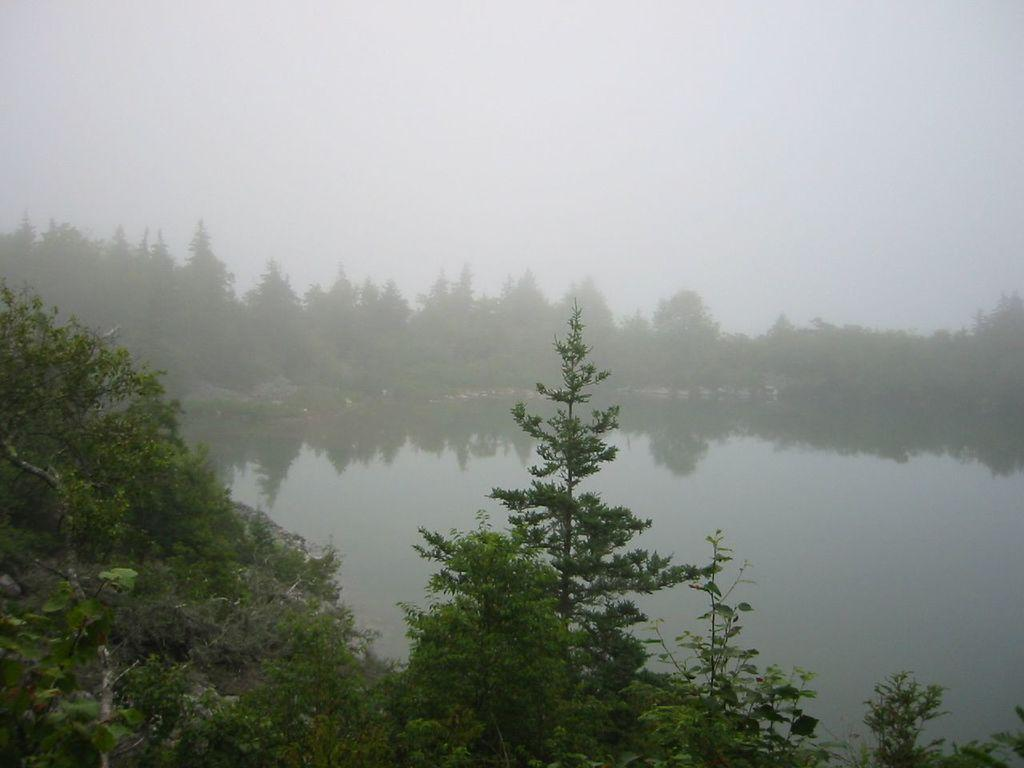What type of vegetation can be seen in the image? There are trees in the image. What natural element is visible alongside the trees? There is water visible in the image. What part of the natural environment is visible in the image? The sky is visible in the image. What type of amusement can be seen in the image? There is no amusement present in the image; it features trees, water, and the sky. What type of stem is visible in the image? There is no stem present in the image; it features trees, water, and the sky. 